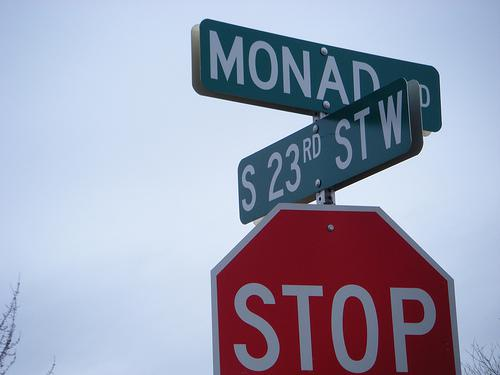Question: what does the top sign say?
Choices:
A. Monad.
B. Drive like your kids play here.
C. Yield to pedestrians.
D. Don't turn right on red.
Answer with the letter. Answer: A Question: what does the middle sign say?
Choices:
A. Stop.
B. Yield.
C. U-Turn.
D. S 23rd St W.
Answer with the letter. Answer: D Question: how do you know where your at?
Choices:
A. Location services on my mobile device.
B. My familiar surroundings.
C. My car's GPS.
D. Top signs.
Answer with the letter. Answer: D Question: where would these signs be located?
Choices:
A. An intersection.
B. In front of the school.
C. At a bus stop.
D. In a shopping mall.
Answer with the letter. Answer: A Question: what are these signs called?
Choices:
A. Street signs.
B. Warnings.
C. Instructions.
D. Advertisements.
Answer with the letter. Answer: A Question: what plants are in the background?
Choices:
A. Trees.
B. Flowers.
C. Weeds.
D. Vines.
Answer with the letter. Answer: A Question: why stop at a stop sign?
Choices:
A. Safety.
B. To not crash into other vehicles.
C. To prevent hitting pedestrians.
D. To obey the law.
Answer with the letter. Answer: A 